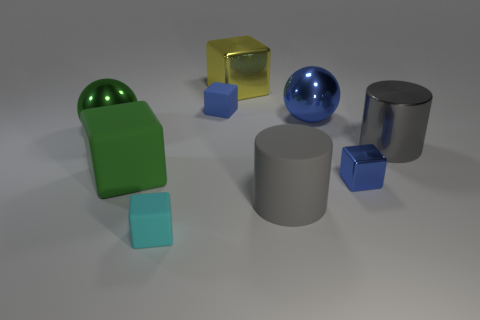What number of large yellow balls are there?
Make the answer very short. 0. There is a tiny cube that is made of the same material as the large yellow block; what is its color?
Your answer should be compact. Blue. How many tiny objects are gray cylinders or blue things?
Your answer should be compact. 2. There is a large shiny cube; how many metal things are in front of it?
Provide a succinct answer. 4. What color is the large shiny object that is the same shape as the big green rubber object?
Your answer should be compact. Yellow. What number of metallic things are either small cubes or cyan objects?
Offer a terse response. 1. There is a big object behind the large blue sphere behind the metallic cylinder; is there a matte cylinder that is to the left of it?
Give a very brief answer. No. What is the color of the tiny metal object?
Your response must be concise. Blue. Does the small rubber thing behind the matte cylinder have the same shape as the gray metallic object?
Your answer should be very brief. No. What number of objects are either cyan matte objects or tiny matte objects behind the rubber cylinder?
Your answer should be compact. 2. 